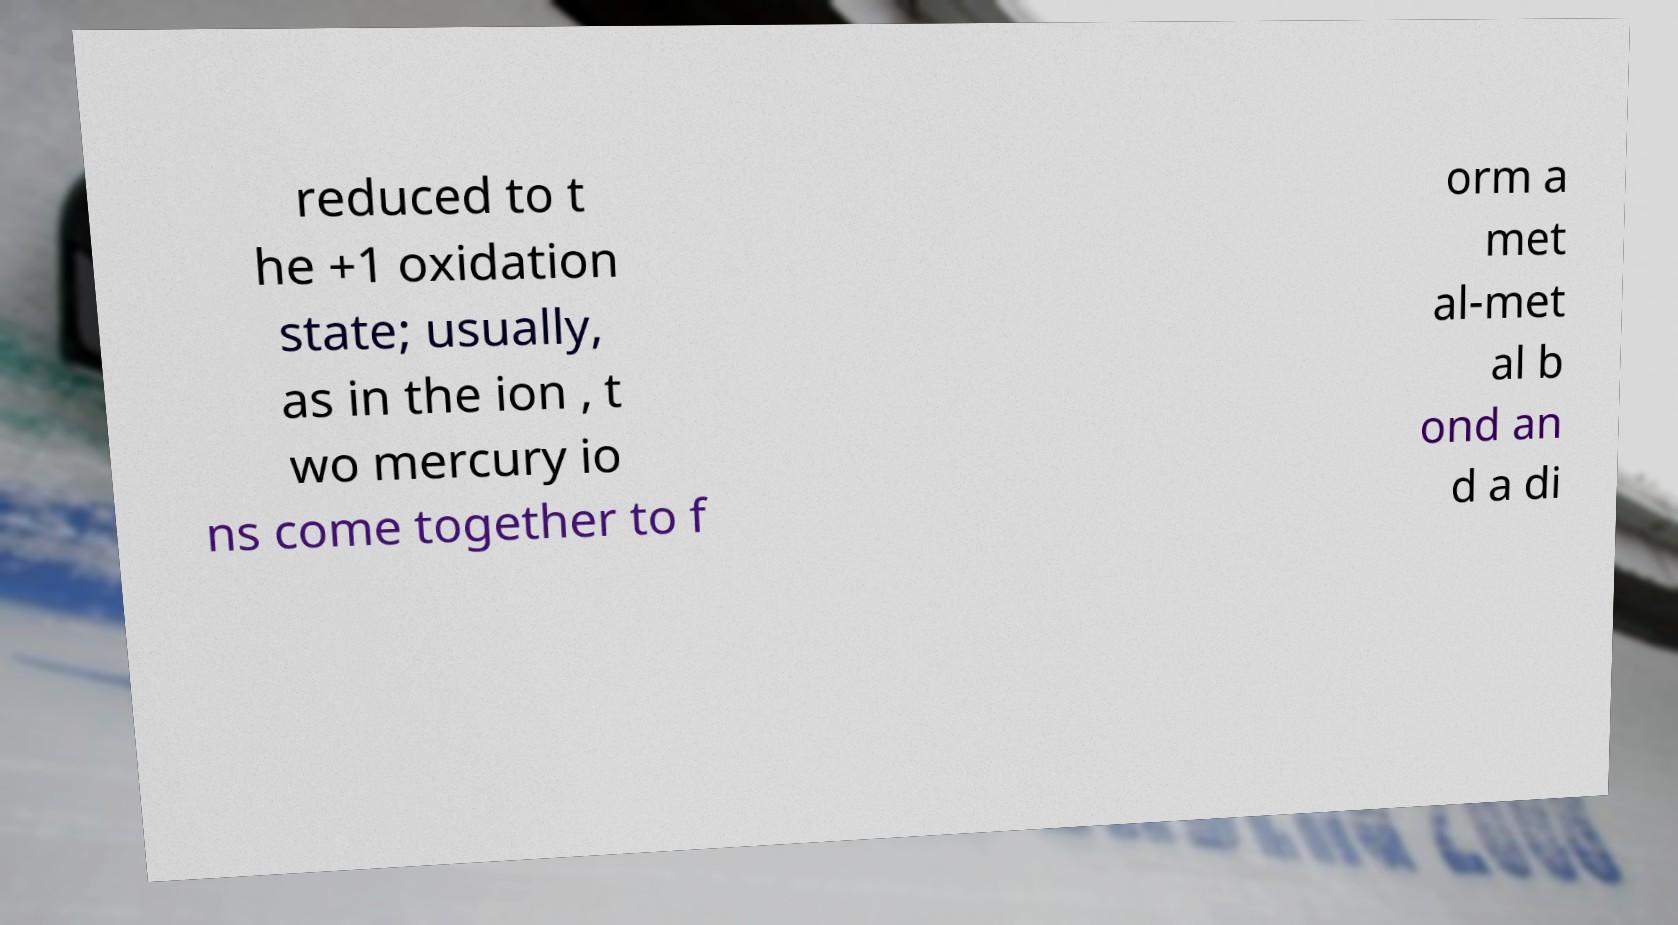What messages or text are displayed in this image? I need them in a readable, typed format. reduced to t he +1 oxidation state; usually, as in the ion , t wo mercury io ns come together to f orm a met al-met al b ond an d a di 